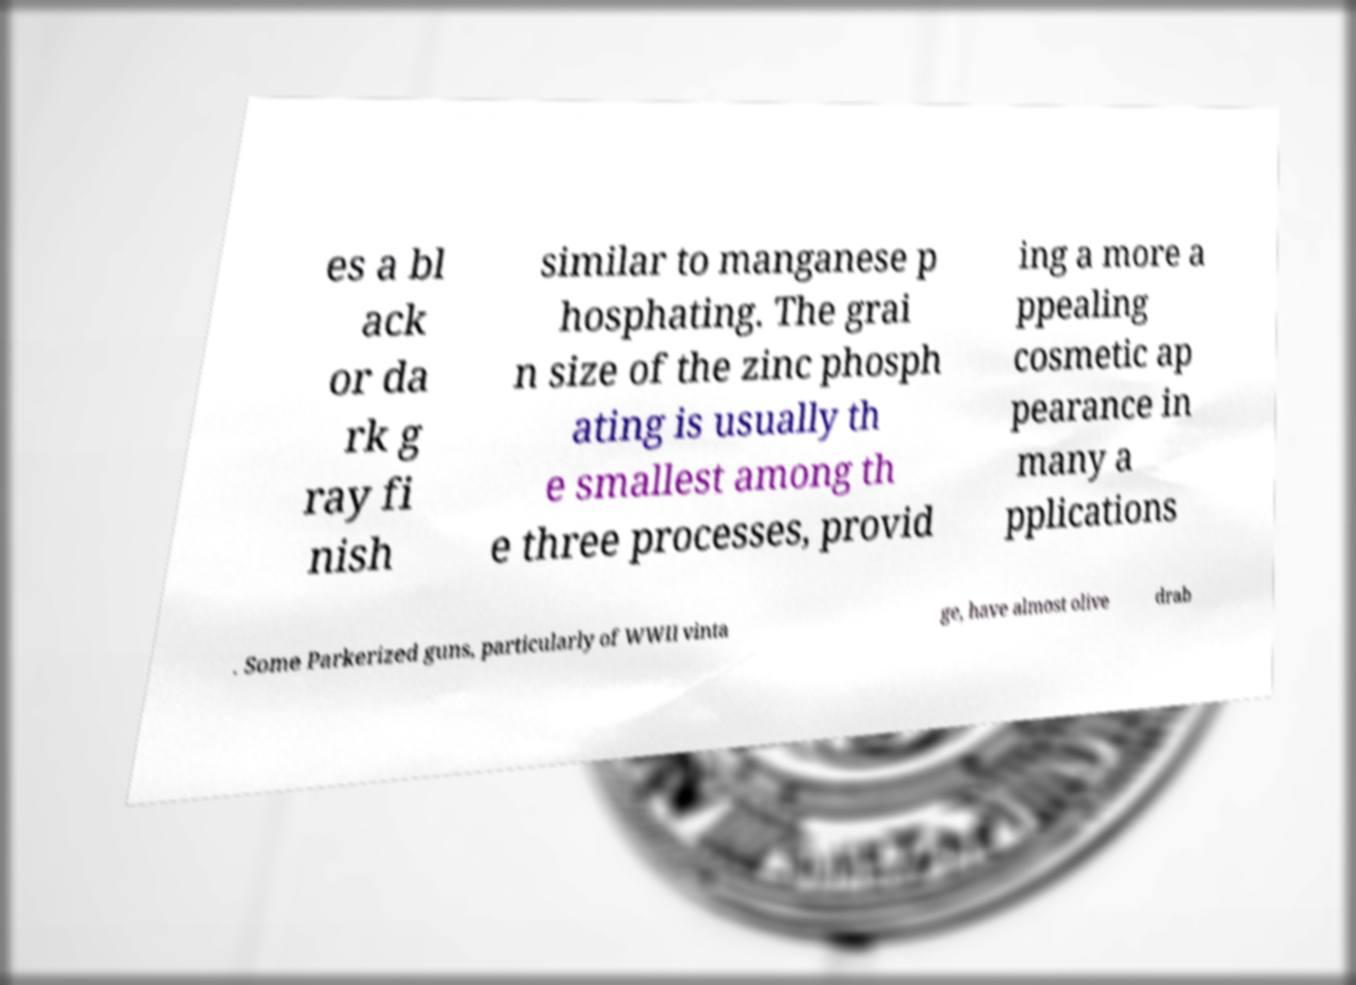Please identify and transcribe the text found in this image. es a bl ack or da rk g ray fi nish similar to manganese p hosphating. The grai n size of the zinc phosph ating is usually th e smallest among th e three processes, provid ing a more a ppealing cosmetic ap pearance in many a pplications . Some Parkerized guns, particularly of WWII vinta ge, have almost olive drab 